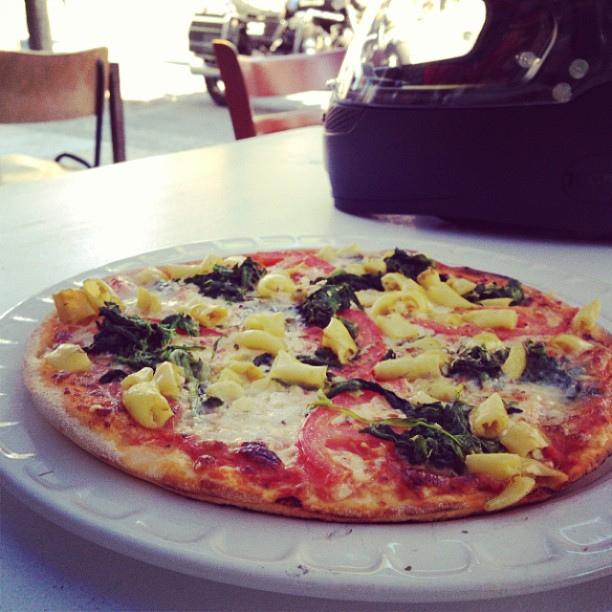What are the chairs made of?
Be succinct. Wood. How many pizzas are shown?
Concise answer only. 1. Is someone sitting at the table?
Keep it brief. No. How many different foods are on the plate?
Concise answer only. 1. Are there other foods on the table?
Quick response, please. No. What is the object next to the pizza?
Be succinct. Helmet. What is the most prominent topping?
Give a very brief answer. Pineapple. 